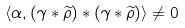<formula> <loc_0><loc_0><loc_500><loc_500>\langle \alpha , ( \gamma * \widetilde { \rho } ) * ( \gamma * \widetilde { \rho } ) \rangle \neq 0</formula> 